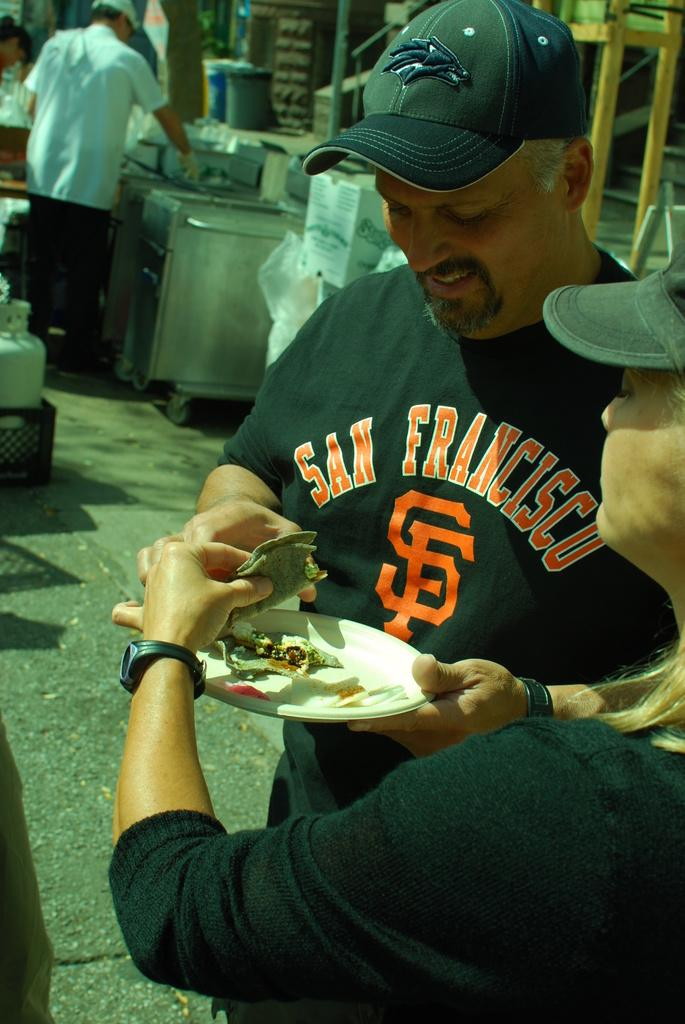What are the man and woman in the image wearing? The man and woman are both wearing black t-shirts and caps. What are they doing in the image? The man and woman are standing on the road and eating street food. Where can you find the source of the street food they are eating? There is a street food shop in the background of the image. What type of fork is the man using to eat the street food in the image? There is no fork present in the image; the man and woman are eating street food using their hands. Can you give an example of another street food shop in the image? There is only one street food shop visible in the image. 